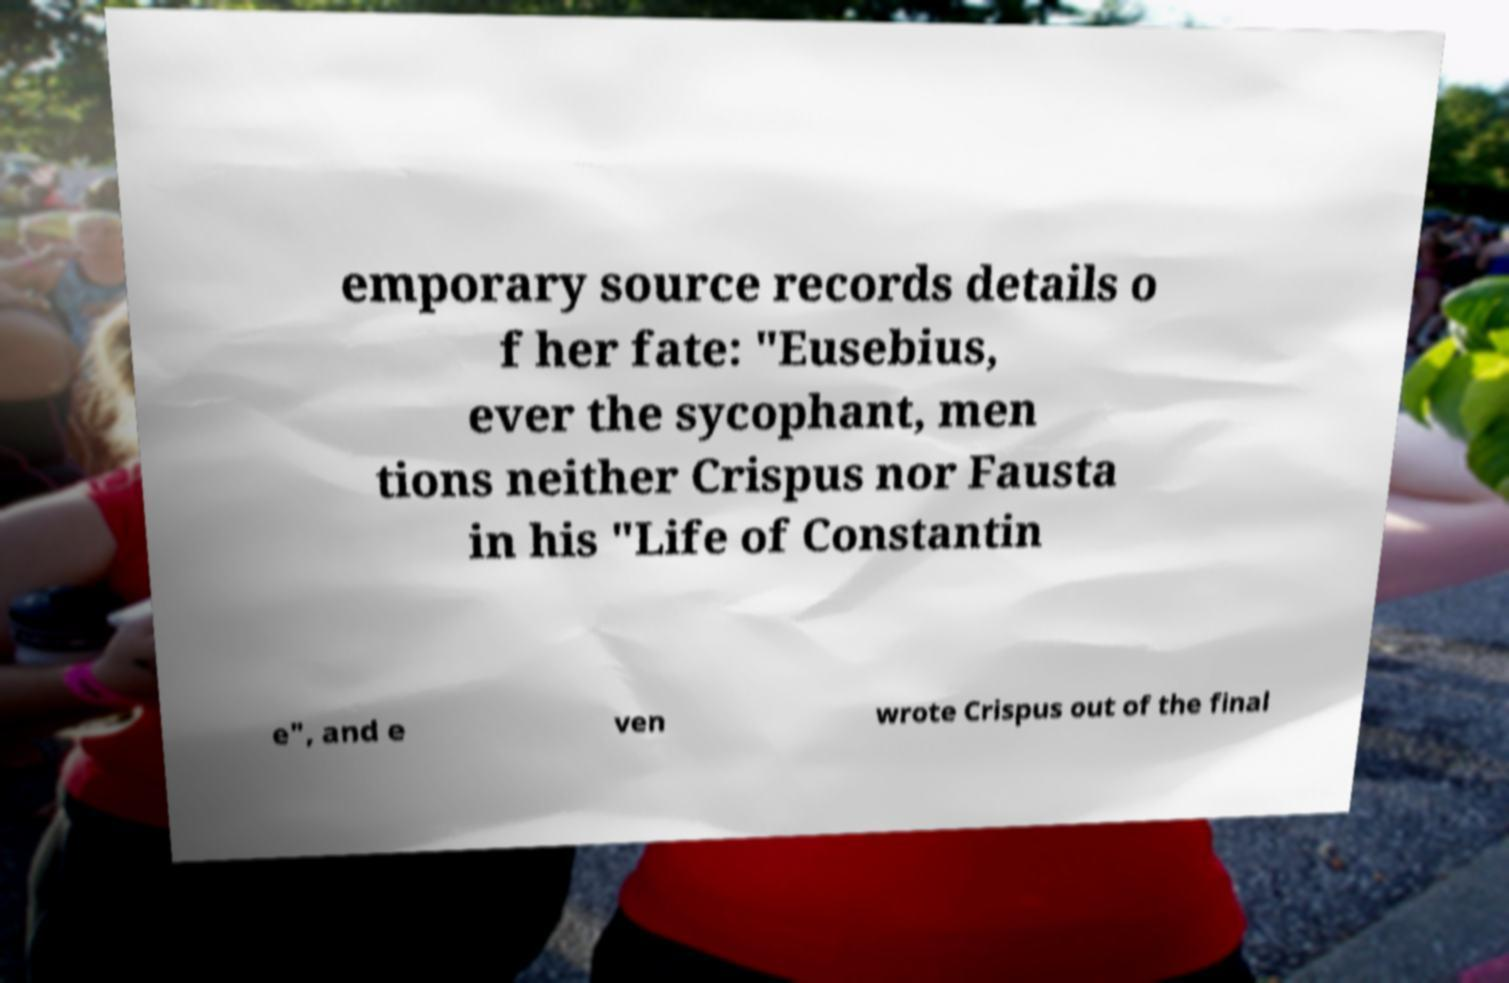What messages or text are displayed in this image? I need them in a readable, typed format. emporary source records details o f her fate: "Eusebius, ever the sycophant, men tions neither Crispus nor Fausta in his "Life of Constantin e", and e ven wrote Crispus out of the final 